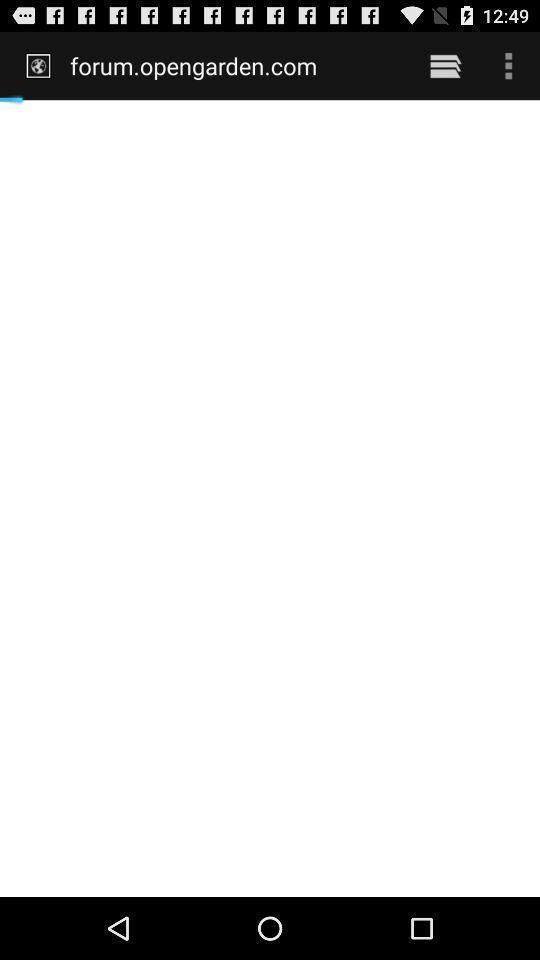Provide a textual representation of this image. Page which is still loading. 